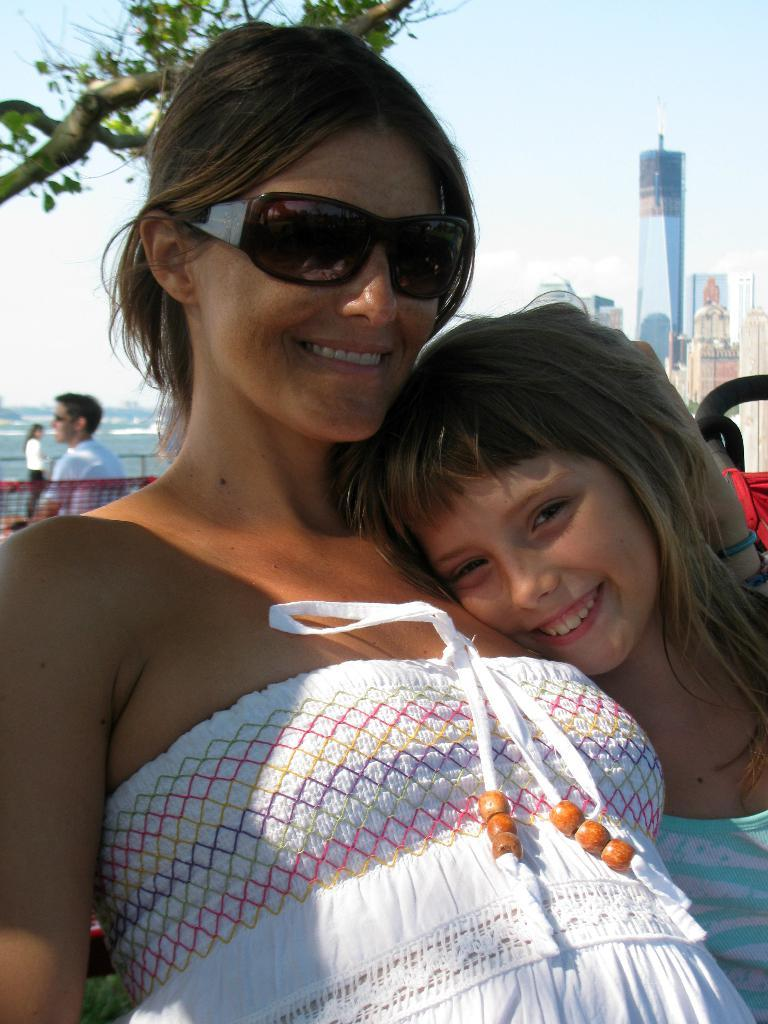Who is present in the image? There is a woman and a child in the image. What type of structures can be seen in the image? There are buildings in the image. What natural element is present in the image? There is a tree in the image. What type of map is the woman holding in the image? There is no map present in the image. 